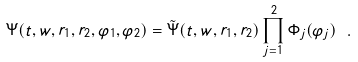Convert formula to latex. <formula><loc_0><loc_0><loc_500><loc_500>\Psi ( t , w , r _ { 1 } , r _ { 2 } , \varphi _ { 1 } , \varphi _ { 2 } ) = \tilde { \Psi } ( t , w , r _ { 1 } , r _ { 2 } ) \prod _ { j = 1 } ^ { 2 } \Phi _ { j } ( \varphi _ { j } ) \ .</formula> 